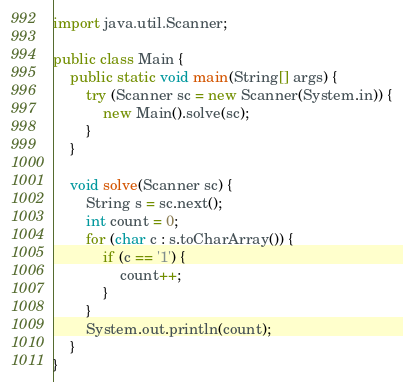Convert code to text. <code><loc_0><loc_0><loc_500><loc_500><_Java_>import java.util.Scanner;

public class Main {
    public static void main(String[] args) {
        try (Scanner sc = new Scanner(System.in)) {
            new Main().solve(sc);
        }
    }

    void solve(Scanner sc) {
        String s = sc.next();
        int count = 0;
        for (char c : s.toCharArray()) {
            if (c == '1') {
                count++;
            }
        }
        System.out.println(count);
    }
}
</code> 